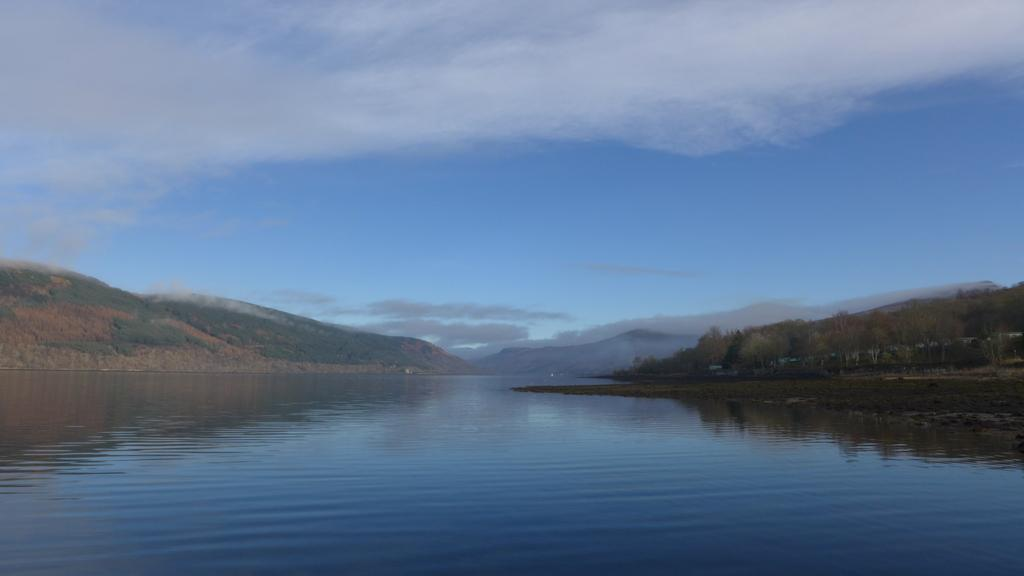What is the main subject in the center of the image? There is water in the center of the image. What can be seen in the background of the image? There are trees and mountains in the background of the image. What else is visible in the background of the image? The sky is visible in the background of the image. What type of jail can be seen in the image? There is no jail present in the image. Can you see any bananas hanging from the trees in the image? There are no bananas visible in the image; only trees are present. 